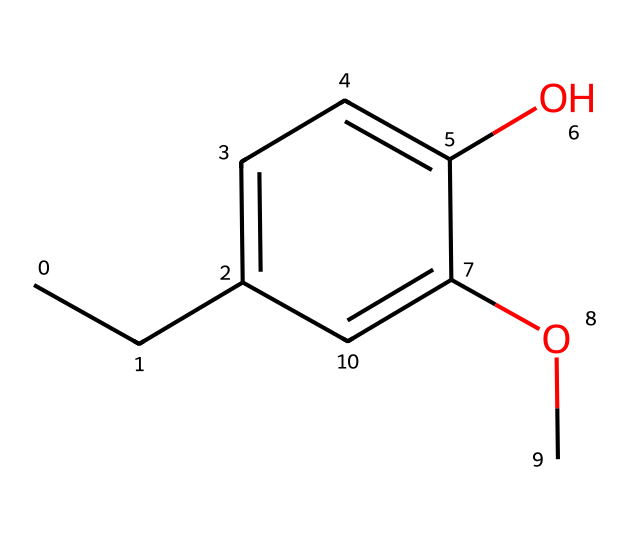What is the IUPAC name of this chemical? The structure reveals the presence of a phenolic ring with an ether substituent (methoxy group) and a propyl side chain. Based on this structure, the IUPAC name is 4-allyl-2-methoxyphenol.
Answer: 4-allyl-2-methoxyphenol How many carbon atoms are in this compound? Counting the carbon atoms in the provided structure, there are a total of 10 carbon atoms: 6 from the aromatic ring and 4 from the propyl and methoxy groups.
Answer: 10 What type of functional group is present in this compound? The structure contains a methoxy group (-OCH3) attached to the aromatic ring, indicating the presence of an ether functional group.
Answer: ether What is the molecular formula of this compound? By adding up the counts of carbon, hydrogen, and oxygen from the structure, the molecular formula is determined to be C10H12O3.
Answer: C10H12O3 Does this compound exhibit any aromatic character? The presence of a phenolic ring demonstrates that this compound has aromatic character due to the delocalized electrons in the cyclic structure.
Answer: yes What type of specific interactions might this compound participate in due to its ether group? The ether group can participate in dipole-dipole interactions due to its polar nature, but it may not partake in hydrogen bonding because there is no hydrogen directly attached to the oxygen.
Answer: dipole-dipole interactions 